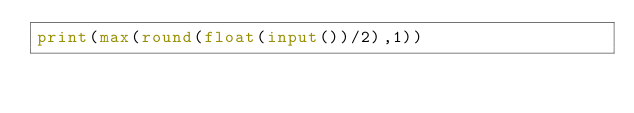<code> <loc_0><loc_0><loc_500><loc_500><_Python_>print(max(round(float(input())/2),1))</code> 